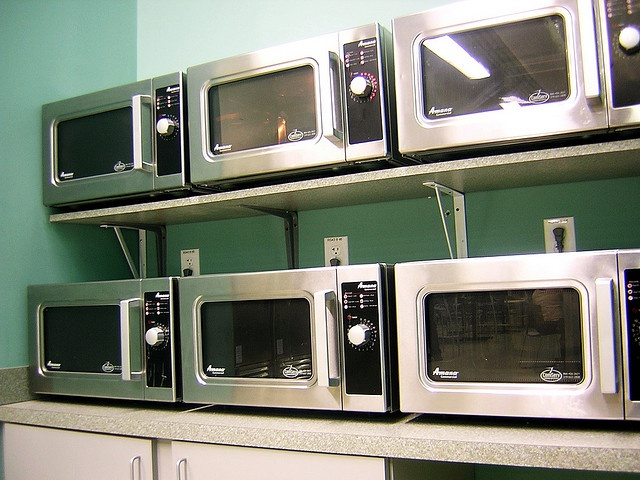Describe the objects in this image and their specific colors. I can see microwave in teal, lightgray, black, tan, and darkgreen tones, microwave in teal, white, gray, and tan tones, microwave in teal, white, gray, black, and darkgray tones, microwave in teal, black, white, darkgray, and gray tones, and microwave in teal, black, darkgreen, and lightgray tones in this image. 